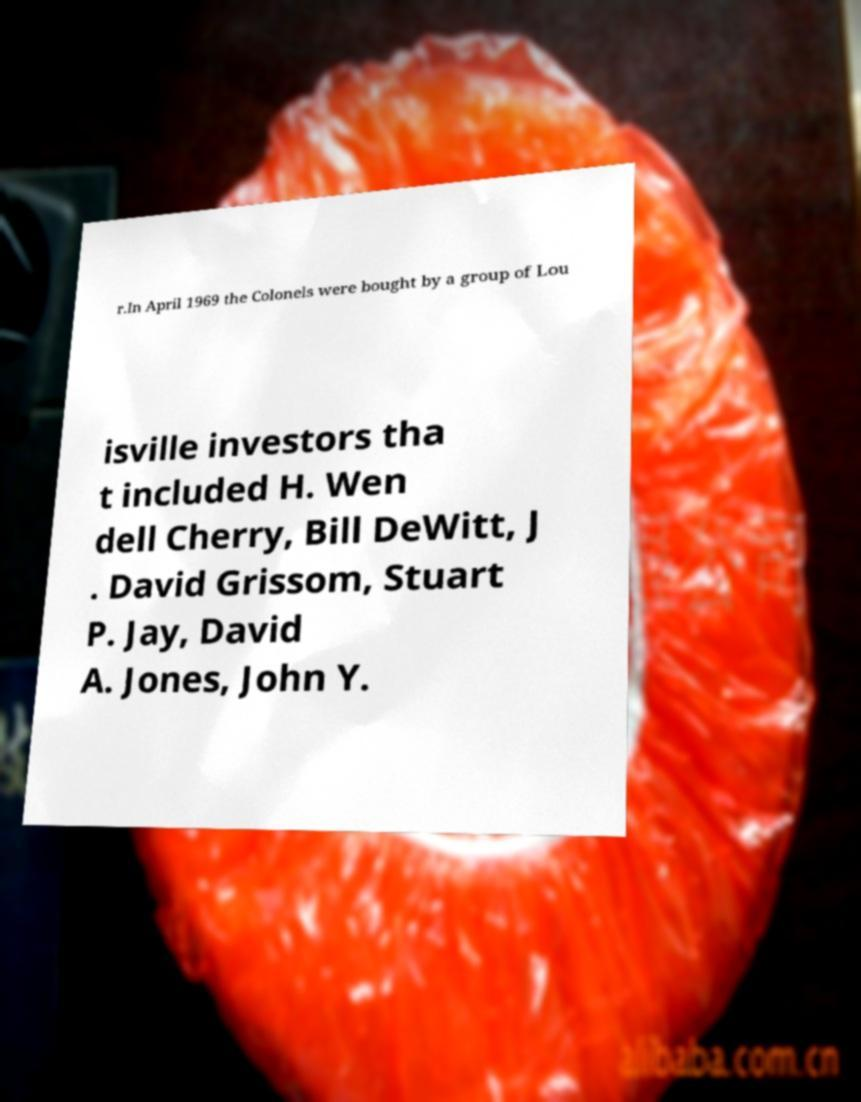There's text embedded in this image that I need extracted. Can you transcribe it verbatim? r.In April 1969 the Colonels were bought by a group of Lou isville investors tha t included H. Wen dell Cherry, Bill DeWitt, J . David Grissom, Stuart P. Jay, David A. Jones, John Y. 